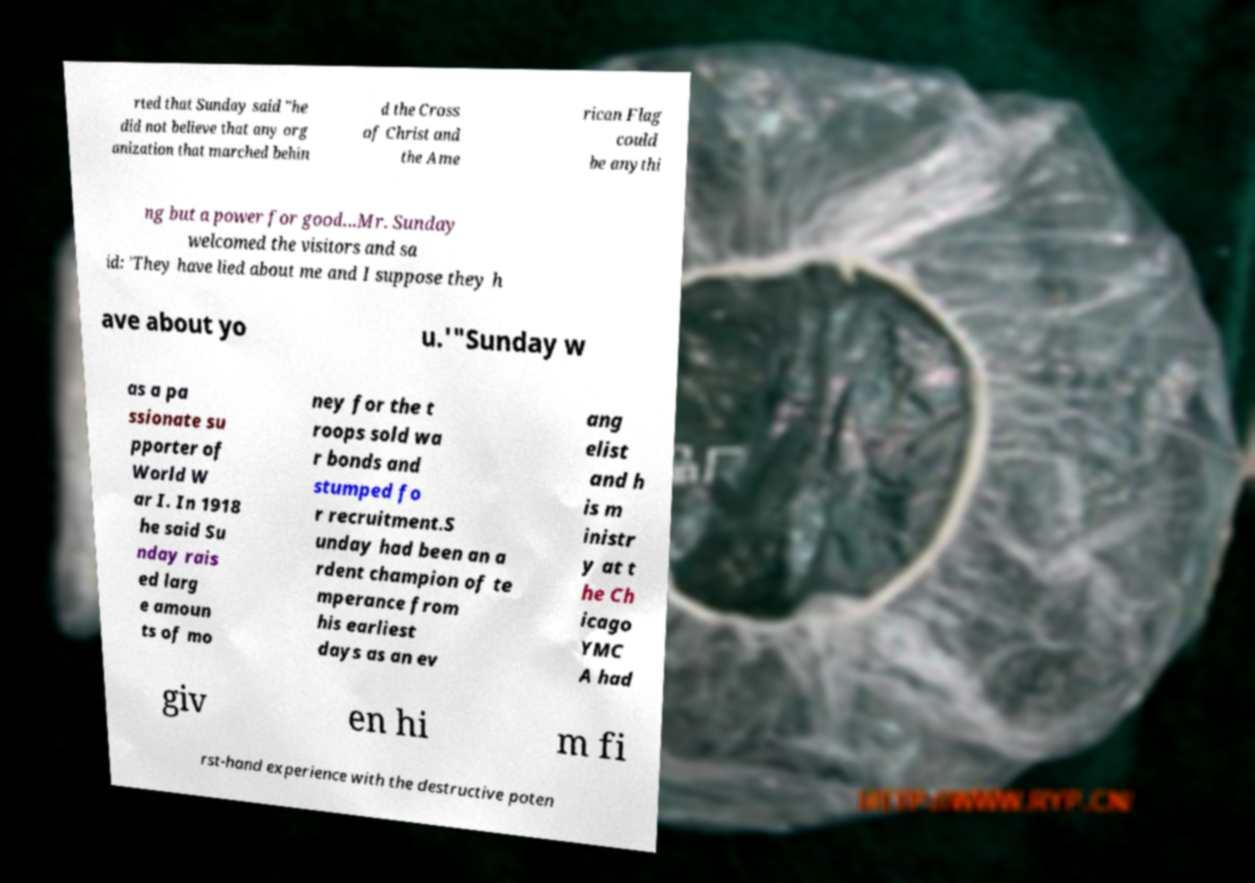For documentation purposes, I need the text within this image transcribed. Could you provide that? rted that Sunday said "he did not believe that any org anization that marched behin d the Cross of Christ and the Ame rican Flag could be anythi ng but a power for good...Mr. Sunday welcomed the visitors and sa id: 'They have lied about me and I suppose they h ave about yo u.'"Sunday w as a pa ssionate su pporter of World W ar I. In 1918 he said Su nday rais ed larg e amoun ts of mo ney for the t roops sold wa r bonds and stumped fo r recruitment.S unday had been an a rdent champion of te mperance from his earliest days as an ev ang elist and h is m inistr y at t he Ch icago YMC A had giv en hi m fi rst-hand experience with the destructive poten 